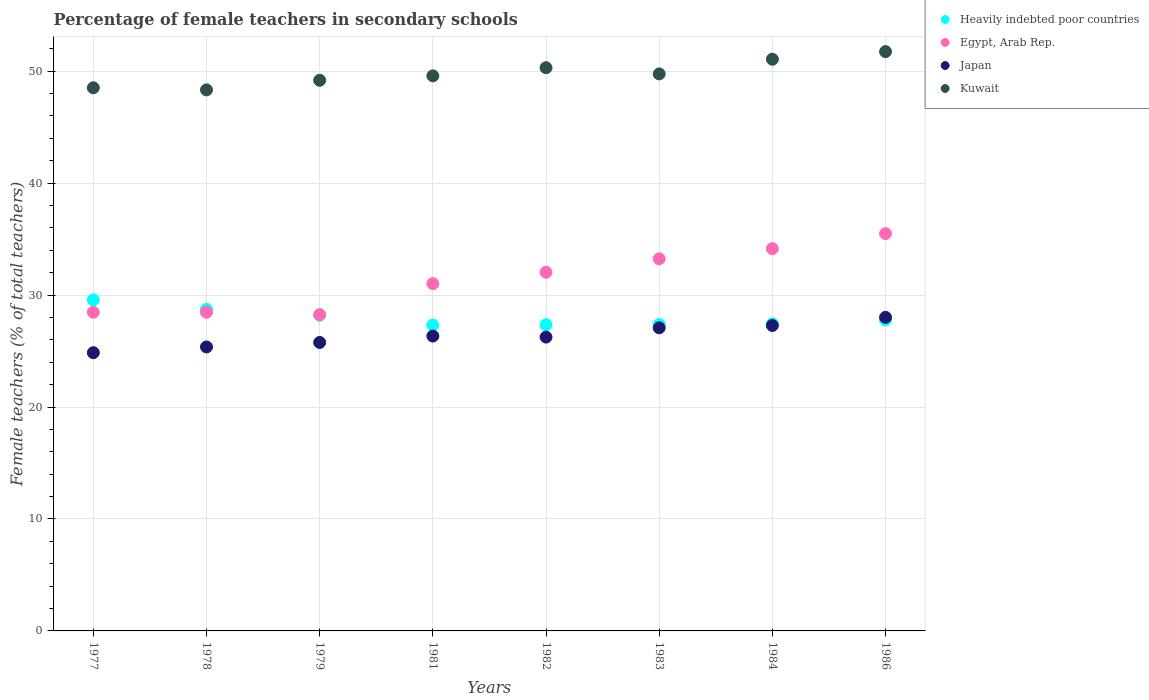Is the number of dotlines equal to the number of legend labels?
Offer a terse response. Yes. What is the percentage of female teachers in Kuwait in 1978?
Ensure brevity in your answer.  48.33. Across all years, what is the maximum percentage of female teachers in Heavily indebted poor countries?
Offer a terse response. 29.57. Across all years, what is the minimum percentage of female teachers in Kuwait?
Provide a succinct answer. 48.33. In which year was the percentage of female teachers in Kuwait minimum?
Give a very brief answer. 1978. What is the total percentage of female teachers in Heavily indebted poor countries in the graph?
Give a very brief answer. 223.78. What is the difference between the percentage of female teachers in Kuwait in 1978 and that in 1983?
Your answer should be very brief. -1.43. What is the difference between the percentage of female teachers in Egypt, Arab Rep. in 1979 and the percentage of female teachers in Kuwait in 1978?
Make the answer very short. -20.07. What is the average percentage of female teachers in Japan per year?
Ensure brevity in your answer.  26.37. In the year 1979, what is the difference between the percentage of female teachers in Egypt, Arab Rep. and percentage of female teachers in Japan?
Your response must be concise. 2.49. In how many years, is the percentage of female teachers in Kuwait greater than 30 %?
Provide a succinct answer. 8. What is the ratio of the percentage of female teachers in Egypt, Arab Rep. in 1979 to that in 1983?
Your answer should be very brief. 0.85. What is the difference between the highest and the second highest percentage of female teachers in Egypt, Arab Rep.?
Ensure brevity in your answer.  1.35. What is the difference between the highest and the lowest percentage of female teachers in Egypt, Arab Rep.?
Ensure brevity in your answer.  7.24. In how many years, is the percentage of female teachers in Japan greater than the average percentage of female teachers in Japan taken over all years?
Provide a succinct answer. 3. Is the sum of the percentage of female teachers in Egypt, Arab Rep. in 1978 and 1986 greater than the maximum percentage of female teachers in Japan across all years?
Your response must be concise. Yes. Is it the case that in every year, the sum of the percentage of female teachers in Heavily indebted poor countries and percentage of female teachers in Japan  is greater than the sum of percentage of female teachers in Egypt, Arab Rep. and percentage of female teachers in Kuwait?
Provide a succinct answer. Yes. Does the percentage of female teachers in Kuwait monotonically increase over the years?
Provide a short and direct response. No. How many dotlines are there?
Make the answer very short. 4. How many years are there in the graph?
Your response must be concise. 8. Does the graph contain any zero values?
Give a very brief answer. No. Where does the legend appear in the graph?
Keep it short and to the point. Top right. What is the title of the graph?
Your response must be concise. Percentage of female teachers in secondary schools. What is the label or title of the X-axis?
Give a very brief answer. Years. What is the label or title of the Y-axis?
Offer a terse response. Female teachers (% of total teachers). What is the Female teachers (% of total teachers) in Heavily indebted poor countries in 1977?
Your answer should be very brief. 29.57. What is the Female teachers (% of total teachers) of Egypt, Arab Rep. in 1977?
Ensure brevity in your answer.  28.47. What is the Female teachers (% of total teachers) of Japan in 1977?
Your answer should be compact. 24.85. What is the Female teachers (% of total teachers) of Kuwait in 1977?
Keep it short and to the point. 48.52. What is the Female teachers (% of total teachers) in Heavily indebted poor countries in 1978?
Your response must be concise. 28.73. What is the Female teachers (% of total teachers) in Egypt, Arab Rep. in 1978?
Your response must be concise. 28.46. What is the Female teachers (% of total teachers) of Japan in 1978?
Provide a succinct answer. 25.37. What is the Female teachers (% of total teachers) of Kuwait in 1978?
Make the answer very short. 48.33. What is the Female teachers (% of total teachers) of Heavily indebted poor countries in 1979?
Ensure brevity in your answer.  28.2. What is the Female teachers (% of total teachers) of Egypt, Arab Rep. in 1979?
Provide a succinct answer. 28.26. What is the Female teachers (% of total teachers) of Japan in 1979?
Offer a very short reply. 25.77. What is the Female teachers (% of total teachers) in Kuwait in 1979?
Your answer should be compact. 49.19. What is the Female teachers (% of total teachers) of Heavily indebted poor countries in 1981?
Your response must be concise. 27.32. What is the Female teachers (% of total teachers) in Egypt, Arab Rep. in 1981?
Keep it short and to the point. 31.03. What is the Female teachers (% of total teachers) in Japan in 1981?
Your answer should be compact. 26.34. What is the Female teachers (% of total teachers) of Kuwait in 1981?
Your response must be concise. 49.58. What is the Female teachers (% of total teachers) in Heavily indebted poor countries in 1982?
Provide a succinct answer. 27.36. What is the Female teachers (% of total teachers) of Egypt, Arab Rep. in 1982?
Keep it short and to the point. 32.04. What is the Female teachers (% of total teachers) of Japan in 1982?
Provide a short and direct response. 26.25. What is the Female teachers (% of total teachers) of Kuwait in 1982?
Your response must be concise. 50.31. What is the Female teachers (% of total teachers) in Heavily indebted poor countries in 1983?
Provide a succinct answer. 27.38. What is the Female teachers (% of total teachers) of Egypt, Arab Rep. in 1983?
Your answer should be very brief. 33.24. What is the Female teachers (% of total teachers) of Japan in 1983?
Make the answer very short. 27.08. What is the Female teachers (% of total teachers) in Kuwait in 1983?
Provide a short and direct response. 49.76. What is the Female teachers (% of total teachers) in Heavily indebted poor countries in 1984?
Your answer should be compact. 27.44. What is the Female teachers (% of total teachers) in Egypt, Arab Rep. in 1984?
Offer a very short reply. 34.15. What is the Female teachers (% of total teachers) in Japan in 1984?
Keep it short and to the point. 27.28. What is the Female teachers (% of total teachers) of Kuwait in 1984?
Offer a terse response. 51.07. What is the Female teachers (% of total teachers) in Heavily indebted poor countries in 1986?
Offer a very short reply. 27.79. What is the Female teachers (% of total teachers) of Egypt, Arab Rep. in 1986?
Give a very brief answer. 35.49. What is the Female teachers (% of total teachers) of Japan in 1986?
Offer a terse response. 28.01. What is the Female teachers (% of total teachers) of Kuwait in 1986?
Provide a succinct answer. 51.75. Across all years, what is the maximum Female teachers (% of total teachers) in Heavily indebted poor countries?
Offer a terse response. 29.57. Across all years, what is the maximum Female teachers (% of total teachers) in Egypt, Arab Rep.?
Ensure brevity in your answer.  35.49. Across all years, what is the maximum Female teachers (% of total teachers) of Japan?
Ensure brevity in your answer.  28.01. Across all years, what is the maximum Female teachers (% of total teachers) in Kuwait?
Make the answer very short. 51.75. Across all years, what is the minimum Female teachers (% of total teachers) in Heavily indebted poor countries?
Provide a succinct answer. 27.32. Across all years, what is the minimum Female teachers (% of total teachers) in Egypt, Arab Rep.?
Keep it short and to the point. 28.26. Across all years, what is the minimum Female teachers (% of total teachers) of Japan?
Your response must be concise. 24.85. Across all years, what is the minimum Female teachers (% of total teachers) of Kuwait?
Keep it short and to the point. 48.33. What is the total Female teachers (% of total teachers) of Heavily indebted poor countries in the graph?
Provide a short and direct response. 223.78. What is the total Female teachers (% of total teachers) of Egypt, Arab Rep. in the graph?
Your response must be concise. 251.14. What is the total Female teachers (% of total teachers) in Japan in the graph?
Give a very brief answer. 210.95. What is the total Female teachers (% of total teachers) of Kuwait in the graph?
Provide a succinct answer. 398.5. What is the difference between the Female teachers (% of total teachers) in Heavily indebted poor countries in 1977 and that in 1978?
Your response must be concise. 0.84. What is the difference between the Female teachers (% of total teachers) of Egypt, Arab Rep. in 1977 and that in 1978?
Your answer should be compact. 0. What is the difference between the Female teachers (% of total teachers) in Japan in 1977 and that in 1978?
Provide a succinct answer. -0.51. What is the difference between the Female teachers (% of total teachers) in Kuwait in 1977 and that in 1978?
Give a very brief answer. 0.19. What is the difference between the Female teachers (% of total teachers) of Heavily indebted poor countries in 1977 and that in 1979?
Provide a short and direct response. 1.37. What is the difference between the Female teachers (% of total teachers) in Egypt, Arab Rep. in 1977 and that in 1979?
Your answer should be very brief. 0.21. What is the difference between the Female teachers (% of total teachers) of Japan in 1977 and that in 1979?
Ensure brevity in your answer.  -0.91. What is the difference between the Female teachers (% of total teachers) in Kuwait in 1977 and that in 1979?
Keep it short and to the point. -0.67. What is the difference between the Female teachers (% of total teachers) in Heavily indebted poor countries in 1977 and that in 1981?
Make the answer very short. 2.25. What is the difference between the Female teachers (% of total teachers) in Egypt, Arab Rep. in 1977 and that in 1981?
Your answer should be very brief. -2.56. What is the difference between the Female teachers (% of total teachers) in Japan in 1977 and that in 1981?
Give a very brief answer. -1.49. What is the difference between the Female teachers (% of total teachers) of Kuwait in 1977 and that in 1981?
Your response must be concise. -1.07. What is the difference between the Female teachers (% of total teachers) of Heavily indebted poor countries in 1977 and that in 1982?
Offer a very short reply. 2.21. What is the difference between the Female teachers (% of total teachers) in Egypt, Arab Rep. in 1977 and that in 1982?
Offer a terse response. -3.57. What is the difference between the Female teachers (% of total teachers) of Japan in 1977 and that in 1982?
Your answer should be compact. -1.39. What is the difference between the Female teachers (% of total teachers) in Kuwait in 1977 and that in 1982?
Make the answer very short. -1.79. What is the difference between the Female teachers (% of total teachers) of Heavily indebted poor countries in 1977 and that in 1983?
Ensure brevity in your answer.  2.19. What is the difference between the Female teachers (% of total teachers) in Egypt, Arab Rep. in 1977 and that in 1983?
Your response must be concise. -4.78. What is the difference between the Female teachers (% of total teachers) in Japan in 1977 and that in 1983?
Make the answer very short. -2.22. What is the difference between the Female teachers (% of total teachers) of Kuwait in 1977 and that in 1983?
Make the answer very short. -1.24. What is the difference between the Female teachers (% of total teachers) of Heavily indebted poor countries in 1977 and that in 1984?
Your response must be concise. 2.14. What is the difference between the Female teachers (% of total teachers) of Egypt, Arab Rep. in 1977 and that in 1984?
Keep it short and to the point. -5.68. What is the difference between the Female teachers (% of total teachers) of Japan in 1977 and that in 1984?
Make the answer very short. -2.43. What is the difference between the Female teachers (% of total teachers) in Kuwait in 1977 and that in 1984?
Your response must be concise. -2.55. What is the difference between the Female teachers (% of total teachers) in Heavily indebted poor countries in 1977 and that in 1986?
Ensure brevity in your answer.  1.79. What is the difference between the Female teachers (% of total teachers) in Egypt, Arab Rep. in 1977 and that in 1986?
Make the answer very short. -7.03. What is the difference between the Female teachers (% of total teachers) in Japan in 1977 and that in 1986?
Give a very brief answer. -3.16. What is the difference between the Female teachers (% of total teachers) of Kuwait in 1977 and that in 1986?
Offer a very short reply. -3.23. What is the difference between the Female teachers (% of total teachers) in Heavily indebted poor countries in 1978 and that in 1979?
Ensure brevity in your answer.  0.54. What is the difference between the Female teachers (% of total teachers) in Egypt, Arab Rep. in 1978 and that in 1979?
Ensure brevity in your answer.  0.21. What is the difference between the Female teachers (% of total teachers) of Japan in 1978 and that in 1979?
Give a very brief answer. -0.4. What is the difference between the Female teachers (% of total teachers) of Kuwait in 1978 and that in 1979?
Your response must be concise. -0.86. What is the difference between the Female teachers (% of total teachers) of Heavily indebted poor countries in 1978 and that in 1981?
Your answer should be compact. 1.41. What is the difference between the Female teachers (% of total teachers) in Egypt, Arab Rep. in 1978 and that in 1981?
Make the answer very short. -2.56. What is the difference between the Female teachers (% of total teachers) of Japan in 1978 and that in 1981?
Offer a very short reply. -0.97. What is the difference between the Female teachers (% of total teachers) in Kuwait in 1978 and that in 1981?
Make the answer very short. -1.25. What is the difference between the Female teachers (% of total teachers) in Heavily indebted poor countries in 1978 and that in 1982?
Provide a succinct answer. 1.38. What is the difference between the Female teachers (% of total teachers) in Egypt, Arab Rep. in 1978 and that in 1982?
Provide a succinct answer. -3.58. What is the difference between the Female teachers (% of total teachers) in Japan in 1978 and that in 1982?
Offer a terse response. -0.88. What is the difference between the Female teachers (% of total teachers) of Kuwait in 1978 and that in 1982?
Keep it short and to the point. -1.98. What is the difference between the Female teachers (% of total teachers) of Heavily indebted poor countries in 1978 and that in 1983?
Provide a succinct answer. 1.36. What is the difference between the Female teachers (% of total teachers) in Egypt, Arab Rep. in 1978 and that in 1983?
Keep it short and to the point. -4.78. What is the difference between the Female teachers (% of total teachers) of Japan in 1978 and that in 1983?
Provide a short and direct response. -1.71. What is the difference between the Female teachers (% of total teachers) of Kuwait in 1978 and that in 1983?
Keep it short and to the point. -1.43. What is the difference between the Female teachers (% of total teachers) of Heavily indebted poor countries in 1978 and that in 1984?
Your response must be concise. 1.3. What is the difference between the Female teachers (% of total teachers) of Egypt, Arab Rep. in 1978 and that in 1984?
Offer a very short reply. -5.68. What is the difference between the Female teachers (% of total teachers) of Japan in 1978 and that in 1984?
Provide a succinct answer. -1.92. What is the difference between the Female teachers (% of total teachers) of Kuwait in 1978 and that in 1984?
Offer a terse response. -2.74. What is the difference between the Female teachers (% of total teachers) in Heavily indebted poor countries in 1978 and that in 1986?
Keep it short and to the point. 0.95. What is the difference between the Female teachers (% of total teachers) in Egypt, Arab Rep. in 1978 and that in 1986?
Your response must be concise. -7.03. What is the difference between the Female teachers (% of total teachers) in Japan in 1978 and that in 1986?
Make the answer very short. -2.64. What is the difference between the Female teachers (% of total teachers) in Kuwait in 1978 and that in 1986?
Your answer should be compact. -3.42. What is the difference between the Female teachers (% of total teachers) in Heavily indebted poor countries in 1979 and that in 1981?
Ensure brevity in your answer.  0.88. What is the difference between the Female teachers (% of total teachers) in Egypt, Arab Rep. in 1979 and that in 1981?
Make the answer very short. -2.77. What is the difference between the Female teachers (% of total teachers) in Japan in 1979 and that in 1981?
Give a very brief answer. -0.57. What is the difference between the Female teachers (% of total teachers) in Kuwait in 1979 and that in 1981?
Provide a short and direct response. -0.4. What is the difference between the Female teachers (% of total teachers) of Heavily indebted poor countries in 1979 and that in 1982?
Your answer should be very brief. 0.84. What is the difference between the Female teachers (% of total teachers) in Egypt, Arab Rep. in 1979 and that in 1982?
Your response must be concise. -3.78. What is the difference between the Female teachers (% of total teachers) of Japan in 1979 and that in 1982?
Give a very brief answer. -0.48. What is the difference between the Female teachers (% of total teachers) in Kuwait in 1979 and that in 1982?
Your response must be concise. -1.12. What is the difference between the Female teachers (% of total teachers) in Heavily indebted poor countries in 1979 and that in 1983?
Offer a terse response. 0.82. What is the difference between the Female teachers (% of total teachers) of Egypt, Arab Rep. in 1979 and that in 1983?
Your response must be concise. -4.99. What is the difference between the Female teachers (% of total teachers) of Japan in 1979 and that in 1983?
Make the answer very short. -1.31. What is the difference between the Female teachers (% of total teachers) in Kuwait in 1979 and that in 1983?
Offer a terse response. -0.57. What is the difference between the Female teachers (% of total teachers) in Heavily indebted poor countries in 1979 and that in 1984?
Your answer should be compact. 0.76. What is the difference between the Female teachers (% of total teachers) in Egypt, Arab Rep. in 1979 and that in 1984?
Keep it short and to the point. -5.89. What is the difference between the Female teachers (% of total teachers) in Japan in 1979 and that in 1984?
Provide a succinct answer. -1.52. What is the difference between the Female teachers (% of total teachers) in Kuwait in 1979 and that in 1984?
Ensure brevity in your answer.  -1.88. What is the difference between the Female teachers (% of total teachers) in Heavily indebted poor countries in 1979 and that in 1986?
Your response must be concise. 0.41. What is the difference between the Female teachers (% of total teachers) of Egypt, Arab Rep. in 1979 and that in 1986?
Offer a terse response. -7.24. What is the difference between the Female teachers (% of total teachers) in Japan in 1979 and that in 1986?
Give a very brief answer. -2.24. What is the difference between the Female teachers (% of total teachers) in Kuwait in 1979 and that in 1986?
Give a very brief answer. -2.56. What is the difference between the Female teachers (% of total teachers) in Heavily indebted poor countries in 1981 and that in 1982?
Keep it short and to the point. -0.04. What is the difference between the Female teachers (% of total teachers) of Egypt, Arab Rep. in 1981 and that in 1982?
Your answer should be very brief. -1.01. What is the difference between the Female teachers (% of total teachers) of Japan in 1981 and that in 1982?
Your answer should be compact. 0.09. What is the difference between the Female teachers (% of total teachers) of Kuwait in 1981 and that in 1982?
Your answer should be compact. -0.73. What is the difference between the Female teachers (% of total teachers) of Heavily indebted poor countries in 1981 and that in 1983?
Your answer should be very brief. -0.06. What is the difference between the Female teachers (% of total teachers) in Egypt, Arab Rep. in 1981 and that in 1983?
Offer a very short reply. -2.22. What is the difference between the Female teachers (% of total teachers) of Japan in 1981 and that in 1983?
Your answer should be very brief. -0.74. What is the difference between the Female teachers (% of total teachers) of Kuwait in 1981 and that in 1983?
Give a very brief answer. -0.18. What is the difference between the Female teachers (% of total teachers) of Heavily indebted poor countries in 1981 and that in 1984?
Provide a short and direct response. -0.12. What is the difference between the Female teachers (% of total teachers) in Egypt, Arab Rep. in 1981 and that in 1984?
Ensure brevity in your answer.  -3.12. What is the difference between the Female teachers (% of total teachers) in Japan in 1981 and that in 1984?
Make the answer very short. -0.94. What is the difference between the Female teachers (% of total teachers) in Kuwait in 1981 and that in 1984?
Ensure brevity in your answer.  -1.49. What is the difference between the Female teachers (% of total teachers) of Heavily indebted poor countries in 1981 and that in 1986?
Give a very brief answer. -0.46. What is the difference between the Female teachers (% of total teachers) of Egypt, Arab Rep. in 1981 and that in 1986?
Keep it short and to the point. -4.47. What is the difference between the Female teachers (% of total teachers) in Japan in 1981 and that in 1986?
Provide a short and direct response. -1.67. What is the difference between the Female teachers (% of total teachers) in Kuwait in 1981 and that in 1986?
Offer a very short reply. -2.17. What is the difference between the Female teachers (% of total teachers) of Heavily indebted poor countries in 1982 and that in 1983?
Your answer should be very brief. -0.02. What is the difference between the Female teachers (% of total teachers) in Egypt, Arab Rep. in 1982 and that in 1983?
Your answer should be compact. -1.2. What is the difference between the Female teachers (% of total teachers) of Japan in 1982 and that in 1983?
Provide a short and direct response. -0.83. What is the difference between the Female teachers (% of total teachers) of Kuwait in 1982 and that in 1983?
Keep it short and to the point. 0.55. What is the difference between the Female teachers (% of total teachers) of Heavily indebted poor countries in 1982 and that in 1984?
Offer a very short reply. -0.08. What is the difference between the Female teachers (% of total teachers) of Egypt, Arab Rep. in 1982 and that in 1984?
Your answer should be very brief. -2.11. What is the difference between the Female teachers (% of total teachers) of Japan in 1982 and that in 1984?
Make the answer very short. -1.04. What is the difference between the Female teachers (% of total teachers) of Kuwait in 1982 and that in 1984?
Make the answer very short. -0.76. What is the difference between the Female teachers (% of total teachers) in Heavily indebted poor countries in 1982 and that in 1986?
Your answer should be compact. -0.43. What is the difference between the Female teachers (% of total teachers) of Egypt, Arab Rep. in 1982 and that in 1986?
Ensure brevity in your answer.  -3.45. What is the difference between the Female teachers (% of total teachers) in Japan in 1982 and that in 1986?
Offer a very short reply. -1.76. What is the difference between the Female teachers (% of total teachers) of Kuwait in 1982 and that in 1986?
Your answer should be very brief. -1.44. What is the difference between the Female teachers (% of total teachers) of Heavily indebted poor countries in 1983 and that in 1984?
Give a very brief answer. -0.06. What is the difference between the Female teachers (% of total teachers) in Egypt, Arab Rep. in 1983 and that in 1984?
Your response must be concise. -0.9. What is the difference between the Female teachers (% of total teachers) of Japan in 1983 and that in 1984?
Ensure brevity in your answer.  -0.21. What is the difference between the Female teachers (% of total teachers) in Kuwait in 1983 and that in 1984?
Provide a short and direct response. -1.31. What is the difference between the Female teachers (% of total teachers) in Heavily indebted poor countries in 1983 and that in 1986?
Offer a terse response. -0.41. What is the difference between the Female teachers (% of total teachers) in Egypt, Arab Rep. in 1983 and that in 1986?
Your answer should be compact. -2.25. What is the difference between the Female teachers (% of total teachers) of Japan in 1983 and that in 1986?
Offer a very short reply. -0.93. What is the difference between the Female teachers (% of total teachers) of Kuwait in 1983 and that in 1986?
Make the answer very short. -1.99. What is the difference between the Female teachers (% of total teachers) in Heavily indebted poor countries in 1984 and that in 1986?
Offer a terse response. -0.35. What is the difference between the Female teachers (% of total teachers) in Egypt, Arab Rep. in 1984 and that in 1986?
Give a very brief answer. -1.35. What is the difference between the Female teachers (% of total teachers) in Japan in 1984 and that in 1986?
Give a very brief answer. -0.73. What is the difference between the Female teachers (% of total teachers) in Kuwait in 1984 and that in 1986?
Offer a very short reply. -0.68. What is the difference between the Female teachers (% of total teachers) of Heavily indebted poor countries in 1977 and the Female teachers (% of total teachers) of Egypt, Arab Rep. in 1978?
Your answer should be very brief. 1.11. What is the difference between the Female teachers (% of total teachers) of Heavily indebted poor countries in 1977 and the Female teachers (% of total teachers) of Japan in 1978?
Your answer should be very brief. 4.2. What is the difference between the Female teachers (% of total teachers) in Heavily indebted poor countries in 1977 and the Female teachers (% of total teachers) in Kuwait in 1978?
Provide a short and direct response. -18.76. What is the difference between the Female teachers (% of total teachers) of Egypt, Arab Rep. in 1977 and the Female teachers (% of total teachers) of Japan in 1978?
Your answer should be compact. 3.1. What is the difference between the Female teachers (% of total teachers) in Egypt, Arab Rep. in 1977 and the Female teachers (% of total teachers) in Kuwait in 1978?
Your response must be concise. -19.86. What is the difference between the Female teachers (% of total teachers) in Japan in 1977 and the Female teachers (% of total teachers) in Kuwait in 1978?
Make the answer very short. -23.48. What is the difference between the Female teachers (% of total teachers) in Heavily indebted poor countries in 1977 and the Female teachers (% of total teachers) in Egypt, Arab Rep. in 1979?
Your response must be concise. 1.32. What is the difference between the Female teachers (% of total teachers) in Heavily indebted poor countries in 1977 and the Female teachers (% of total teachers) in Japan in 1979?
Offer a very short reply. 3.8. What is the difference between the Female teachers (% of total teachers) in Heavily indebted poor countries in 1977 and the Female teachers (% of total teachers) in Kuwait in 1979?
Ensure brevity in your answer.  -19.62. What is the difference between the Female teachers (% of total teachers) of Egypt, Arab Rep. in 1977 and the Female teachers (% of total teachers) of Japan in 1979?
Provide a succinct answer. 2.7. What is the difference between the Female teachers (% of total teachers) in Egypt, Arab Rep. in 1977 and the Female teachers (% of total teachers) in Kuwait in 1979?
Keep it short and to the point. -20.72. What is the difference between the Female teachers (% of total teachers) of Japan in 1977 and the Female teachers (% of total teachers) of Kuwait in 1979?
Ensure brevity in your answer.  -24.33. What is the difference between the Female teachers (% of total teachers) in Heavily indebted poor countries in 1977 and the Female teachers (% of total teachers) in Egypt, Arab Rep. in 1981?
Give a very brief answer. -1.45. What is the difference between the Female teachers (% of total teachers) of Heavily indebted poor countries in 1977 and the Female teachers (% of total teachers) of Japan in 1981?
Provide a succinct answer. 3.23. What is the difference between the Female teachers (% of total teachers) in Heavily indebted poor countries in 1977 and the Female teachers (% of total teachers) in Kuwait in 1981?
Your answer should be very brief. -20.01. What is the difference between the Female teachers (% of total teachers) of Egypt, Arab Rep. in 1977 and the Female teachers (% of total teachers) of Japan in 1981?
Ensure brevity in your answer.  2.13. What is the difference between the Female teachers (% of total teachers) in Egypt, Arab Rep. in 1977 and the Female teachers (% of total teachers) in Kuwait in 1981?
Provide a short and direct response. -21.12. What is the difference between the Female teachers (% of total teachers) in Japan in 1977 and the Female teachers (% of total teachers) in Kuwait in 1981?
Make the answer very short. -24.73. What is the difference between the Female teachers (% of total teachers) in Heavily indebted poor countries in 1977 and the Female teachers (% of total teachers) in Egypt, Arab Rep. in 1982?
Offer a terse response. -2.47. What is the difference between the Female teachers (% of total teachers) of Heavily indebted poor countries in 1977 and the Female teachers (% of total teachers) of Japan in 1982?
Give a very brief answer. 3.32. What is the difference between the Female teachers (% of total teachers) in Heavily indebted poor countries in 1977 and the Female teachers (% of total teachers) in Kuwait in 1982?
Keep it short and to the point. -20.74. What is the difference between the Female teachers (% of total teachers) in Egypt, Arab Rep. in 1977 and the Female teachers (% of total teachers) in Japan in 1982?
Ensure brevity in your answer.  2.22. What is the difference between the Female teachers (% of total teachers) of Egypt, Arab Rep. in 1977 and the Female teachers (% of total teachers) of Kuwait in 1982?
Your answer should be very brief. -21.84. What is the difference between the Female teachers (% of total teachers) in Japan in 1977 and the Female teachers (% of total teachers) in Kuwait in 1982?
Give a very brief answer. -25.45. What is the difference between the Female teachers (% of total teachers) in Heavily indebted poor countries in 1977 and the Female teachers (% of total teachers) in Egypt, Arab Rep. in 1983?
Provide a succinct answer. -3.67. What is the difference between the Female teachers (% of total teachers) of Heavily indebted poor countries in 1977 and the Female teachers (% of total teachers) of Japan in 1983?
Your answer should be compact. 2.5. What is the difference between the Female teachers (% of total teachers) of Heavily indebted poor countries in 1977 and the Female teachers (% of total teachers) of Kuwait in 1983?
Offer a terse response. -20.19. What is the difference between the Female teachers (% of total teachers) in Egypt, Arab Rep. in 1977 and the Female teachers (% of total teachers) in Japan in 1983?
Offer a very short reply. 1.39. What is the difference between the Female teachers (% of total teachers) of Egypt, Arab Rep. in 1977 and the Female teachers (% of total teachers) of Kuwait in 1983?
Ensure brevity in your answer.  -21.29. What is the difference between the Female teachers (% of total teachers) of Japan in 1977 and the Female teachers (% of total teachers) of Kuwait in 1983?
Provide a short and direct response. -24.9. What is the difference between the Female teachers (% of total teachers) in Heavily indebted poor countries in 1977 and the Female teachers (% of total teachers) in Egypt, Arab Rep. in 1984?
Ensure brevity in your answer.  -4.57. What is the difference between the Female teachers (% of total teachers) of Heavily indebted poor countries in 1977 and the Female teachers (% of total teachers) of Japan in 1984?
Offer a terse response. 2.29. What is the difference between the Female teachers (% of total teachers) in Heavily indebted poor countries in 1977 and the Female teachers (% of total teachers) in Kuwait in 1984?
Keep it short and to the point. -21.5. What is the difference between the Female teachers (% of total teachers) of Egypt, Arab Rep. in 1977 and the Female teachers (% of total teachers) of Japan in 1984?
Offer a very short reply. 1.18. What is the difference between the Female teachers (% of total teachers) in Egypt, Arab Rep. in 1977 and the Female teachers (% of total teachers) in Kuwait in 1984?
Ensure brevity in your answer.  -22.6. What is the difference between the Female teachers (% of total teachers) in Japan in 1977 and the Female teachers (% of total teachers) in Kuwait in 1984?
Keep it short and to the point. -26.22. What is the difference between the Female teachers (% of total teachers) of Heavily indebted poor countries in 1977 and the Female teachers (% of total teachers) of Egypt, Arab Rep. in 1986?
Offer a terse response. -5.92. What is the difference between the Female teachers (% of total teachers) of Heavily indebted poor countries in 1977 and the Female teachers (% of total teachers) of Japan in 1986?
Provide a succinct answer. 1.56. What is the difference between the Female teachers (% of total teachers) in Heavily indebted poor countries in 1977 and the Female teachers (% of total teachers) in Kuwait in 1986?
Provide a short and direct response. -22.18. What is the difference between the Female teachers (% of total teachers) of Egypt, Arab Rep. in 1977 and the Female teachers (% of total teachers) of Japan in 1986?
Provide a short and direct response. 0.46. What is the difference between the Female teachers (% of total teachers) in Egypt, Arab Rep. in 1977 and the Female teachers (% of total teachers) in Kuwait in 1986?
Make the answer very short. -23.28. What is the difference between the Female teachers (% of total teachers) in Japan in 1977 and the Female teachers (% of total teachers) in Kuwait in 1986?
Provide a succinct answer. -26.89. What is the difference between the Female teachers (% of total teachers) in Heavily indebted poor countries in 1978 and the Female teachers (% of total teachers) in Egypt, Arab Rep. in 1979?
Provide a succinct answer. 0.48. What is the difference between the Female teachers (% of total teachers) in Heavily indebted poor countries in 1978 and the Female teachers (% of total teachers) in Japan in 1979?
Your answer should be very brief. 2.97. What is the difference between the Female teachers (% of total teachers) of Heavily indebted poor countries in 1978 and the Female teachers (% of total teachers) of Kuwait in 1979?
Provide a succinct answer. -20.45. What is the difference between the Female teachers (% of total teachers) of Egypt, Arab Rep. in 1978 and the Female teachers (% of total teachers) of Japan in 1979?
Your answer should be compact. 2.7. What is the difference between the Female teachers (% of total teachers) in Egypt, Arab Rep. in 1978 and the Female teachers (% of total teachers) in Kuwait in 1979?
Ensure brevity in your answer.  -20.72. What is the difference between the Female teachers (% of total teachers) of Japan in 1978 and the Female teachers (% of total teachers) of Kuwait in 1979?
Keep it short and to the point. -23.82. What is the difference between the Female teachers (% of total teachers) of Heavily indebted poor countries in 1978 and the Female teachers (% of total teachers) of Egypt, Arab Rep. in 1981?
Your answer should be compact. -2.29. What is the difference between the Female teachers (% of total teachers) in Heavily indebted poor countries in 1978 and the Female teachers (% of total teachers) in Japan in 1981?
Your response must be concise. 2.4. What is the difference between the Female teachers (% of total teachers) in Heavily indebted poor countries in 1978 and the Female teachers (% of total teachers) in Kuwait in 1981?
Your answer should be very brief. -20.85. What is the difference between the Female teachers (% of total teachers) in Egypt, Arab Rep. in 1978 and the Female teachers (% of total teachers) in Japan in 1981?
Provide a short and direct response. 2.12. What is the difference between the Female teachers (% of total teachers) of Egypt, Arab Rep. in 1978 and the Female teachers (% of total teachers) of Kuwait in 1981?
Make the answer very short. -21.12. What is the difference between the Female teachers (% of total teachers) in Japan in 1978 and the Female teachers (% of total teachers) in Kuwait in 1981?
Make the answer very short. -24.22. What is the difference between the Female teachers (% of total teachers) in Heavily indebted poor countries in 1978 and the Female teachers (% of total teachers) in Egypt, Arab Rep. in 1982?
Your response must be concise. -3.31. What is the difference between the Female teachers (% of total teachers) in Heavily indebted poor countries in 1978 and the Female teachers (% of total teachers) in Japan in 1982?
Your answer should be very brief. 2.49. What is the difference between the Female teachers (% of total teachers) in Heavily indebted poor countries in 1978 and the Female teachers (% of total teachers) in Kuwait in 1982?
Your answer should be compact. -21.57. What is the difference between the Female teachers (% of total teachers) in Egypt, Arab Rep. in 1978 and the Female teachers (% of total teachers) in Japan in 1982?
Provide a short and direct response. 2.22. What is the difference between the Female teachers (% of total teachers) of Egypt, Arab Rep. in 1978 and the Female teachers (% of total teachers) of Kuwait in 1982?
Keep it short and to the point. -21.85. What is the difference between the Female teachers (% of total teachers) in Japan in 1978 and the Female teachers (% of total teachers) in Kuwait in 1982?
Offer a terse response. -24.94. What is the difference between the Female teachers (% of total teachers) in Heavily indebted poor countries in 1978 and the Female teachers (% of total teachers) in Egypt, Arab Rep. in 1983?
Offer a very short reply. -4.51. What is the difference between the Female teachers (% of total teachers) in Heavily indebted poor countries in 1978 and the Female teachers (% of total teachers) in Japan in 1983?
Your answer should be very brief. 1.66. What is the difference between the Female teachers (% of total teachers) of Heavily indebted poor countries in 1978 and the Female teachers (% of total teachers) of Kuwait in 1983?
Your response must be concise. -21.02. What is the difference between the Female teachers (% of total teachers) of Egypt, Arab Rep. in 1978 and the Female teachers (% of total teachers) of Japan in 1983?
Provide a short and direct response. 1.39. What is the difference between the Female teachers (% of total teachers) of Egypt, Arab Rep. in 1978 and the Female teachers (% of total teachers) of Kuwait in 1983?
Provide a short and direct response. -21.29. What is the difference between the Female teachers (% of total teachers) of Japan in 1978 and the Female teachers (% of total teachers) of Kuwait in 1983?
Make the answer very short. -24.39. What is the difference between the Female teachers (% of total teachers) in Heavily indebted poor countries in 1978 and the Female teachers (% of total teachers) in Egypt, Arab Rep. in 1984?
Provide a short and direct response. -5.41. What is the difference between the Female teachers (% of total teachers) in Heavily indebted poor countries in 1978 and the Female teachers (% of total teachers) in Japan in 1984?
Your response must be concise. 1.45. What is the difference between the Female teachers (% of total teachers) of Heavily indebted poor countries in 1978 and the Female teachers (% of total teachers) of Kuwait in 1984?
Your response must be concise. -22.33. What is the difference between the Female teachers (% of total teachers) of Egypt, Arab Rep. in 1978 and the Female teachers (% of total teachers) of Japan in 1984?
Ensure brevity in your answer.  1.18. What is the difference between the Female teachers (% of total teachers) of Egypt, Arab Rep. in 1978 and the Female teachers (% of total teachers) of Kuwait in 1984?
Provide a succinct answer. -22.61. What is the difference between the Female teachers (% of total teachers) of Japan in 1978 and the Female teachers (% of total teachers) of Kuwait in 1984?
Give a very brief answer. -25.7. What is the difference between the Female teachers (% of total teachers) in Heavily indebted poor countries in 1978 and the Female teachers (% of total teachers) in Egypt, Arab Rep. in 1986?
Your answer should be compact. -6.76. What is the difference between the Female teachers (% of total teachers) of Heavily indebted poor countries in 1978 and the Female teachers (% of total teachers) of Japan in 1986?
Offer a very short reply. 0.72. What is the difference between the Female teachers (% of total teachers) of Heavily indebted poor countries in 1978 and the Female teachers (% of total teachers) of Kuwait in 1986?
Give a very brief answer. -23.01. What is the difference between the Female teachers (% of total teachers) in Egypt, Arab Rep. in 1978 and the Female teachers (% of total teachers) in Japan in 1986?
Offer a very short reply. 0.45. What is the difference between the Female teachers (% of total teachers) of Egypt, Arab Rep. in 1978 and the Female teachers (% of total teachers) of Kuwait in 1986?
Keep it short and to the point. -23.28. What is the difference between the Female teachers (% of total teachers) of Japan in 1978 and the Female teachers (% of total teachers) of Kuwait in 1986?
Give a very brief answer. -26.38. What is the difference between the Female teachers (% of total teachers) in Heavily indebted poor countries in 1979 and the Female teachers (% of total teachers) in Egypt, Arab Rep. in 1981?
Keep it short and to the point. -2.83. What is the difference between the Female teachers (% of total teachers) of Heavily indebted poor countries in 1979 and the Female teachers (% of total teachers) of Japan in 1981?
Give a very brief answer. 1.86. What is the difference between the Female teachers (% of total teachers) of Heavily indebted poor countries in 1979 and the Female teachers (% of total teachers) of Kuwait in 1981?
Provide a succinct answer. -21.38. What is the difference between the Female teachers (% of total teachers) of Egypt, Arab Rep. in 1979 and the Female teachers (% of total teachers) of Japan in 1981?
Provide a short and direct response. 1.92. What is the difference between the Female teachers (% of total teachers) of Egypt, Arab Rep. in 1979 and the Female teachers (% of total teachers) of Kuwait in 1981?
Provide a short and direct response. -21.33. What is the difference between the Female teachers (% of total teachers) of Japan in 1979 and the Female teachers (% of total teachers) of Kuwait in 1981?
Provide a short and direct response. -23.81. What is the difference between the Female teachers (% of total teachers) in Heavily indebted poor countries in 1979 and the Female teachers (% of total teachers) in Egypt, Arab Rep. in 1982?
Offer a very short reply. -3.84. What is the difference between the Female teachers (% of total teachers) in Heavily indebted poor countries in 1979 and the Female teachers (% of total teachers) in Japan in 1982?
Offer a very short reply. 1.95. What is the difference between the Female teachers (% of total teachers) in Heavily indebted poor countries in 1979 and the Female teachers (% of total teachers) in Kuwait in 1982?
Give a very brief answer. -22.11. What is the difference between the Female teachers (% of total teachers) in Egypt, Arab Rep. in 1979 and the Female teachers (% of total teachers) in Japan in 1982?
Provide a short and direct response. 2.01. What is the difference between the Female teachers (% of total teachers) of Egypt, Arab Rep. in 1979 and the Female teachers (% of total teachers) of Kuwait in 1982?
Offer a very short reply. -22.05. What is the difference between the Female teachers (% of total teachers) of Japan in 1979 and the Female teachers (% of total teachers) of Kuwait in 1982?
Provide a succinct answer. -24.54. What is the difference between the Female teachers (% of total teachers) of Heavily indebted poor countries in 1979 and the Female teachers (% of total teachers) of Egypt, Arab Rep. in 1983?
Provide a short and direct response. -5.04. What is the difference between the Female teachers (% of total teachers) of Heavily indebted poor countries in 1979 and the Female teachers (% of total teachers) of Japan in 1983?
Offer a terse response. 1.12. What is the difference between the Female teachers (% of total teachers) in Heavily indebted poor countries in 1979 and the Female teachers (% of total teachers) in Kuwait in 1983?
Provide a short and direct response. -21.56. What is the difference between the Female teachers (% of total teachers) in Egypt, Arab Rep. in 1979 and the Female teachers (% of total teachers) in Japan in 1983?
Provide a short and direct response. 1.18. What is the difference between the Female teachers (% of total teachers) in Egypt, Arab Rep. in 1979 and the Female teachers (% of total teachers) in Kuwait in 1983?
Provide a short and direct response. -21.5. What is the difference between the Female teachers (% of total teachers) in Japan in 1979 and the Female teachers (% of total teachers) in Kuwait in 1983?
Provide a succinct answer. -23.99. What is the difference between the Female teachers (% of total teachers) of Heavily indebted poor countries in 1979 and the Female teachers (% of total teachers) of Egypt, Arab Rep. in 1984?
Give a very brief answer. -5.95. What is the difference between the Female teachers (% of total teachers) of Heavily indebted poor countries in 1979 and the Female teachers (% of total teachers) of Japan in 1984?
Your answer should be compact. 0.92. What is the difference between the Female teachers (% of total teachers) in Heavily indebted poor countries in 1979 and the Female teachers (% of total teachers) in Kuwait in 1984?
Your answer should be very brief. -22.87. What is the difference between the Female teachers (% of total teachers) of Egypt, Arab Rep. in 1979 and the Female teachers (% of total teachers) of Japan in 1984?
Your answer should be compact. 0.97. What is the difference between the Female teachers (% of total teachers) in Egypt, Arab Rep. in 1979 and the Female teachers (% of total teachers) in Kuwait in 1984?
Offer a very short reply. -22.81. What is the difference between the Female teachers (% of total teachers) in Japan in 1979 and the Female teachers (% of total teachers) in Kuwait in 1984?
Ensure brevity in your answer.  -25.3. What is the difference between the Female teachers (% of total teachers) in Heavily indebted poor countries in 1979 and the Female teachers (% of total teachers) in Egypt, Arab Rep. in 1986?
Offer a very short reply. -7.29. What is the difference between the Female teachers (% of total teachers) of Heavily indebted poor countries in 1979 and the Female teachers (% of total teachers) of Japan in 1986?
Ensure brevity in your answer.  0.19. What is the difference between the Female teachers (% of total teachers) in Heavily indebted poor countries in 1979 and the Female teachers (% of total teachers) in Kuwait in 1986?
Make the answer very short. -23.55. What is the difference between the Female teachers (% of total teachers) in Egypt, Arab Rep. in 1979 and the Female teachers (% of total teachers) in Japan in 1986?
Offer a very short reply. 0.25. What is the difference between the Female teachers (% of total teachers) in Egypt, Arab Rep. in 1979 and the Female teachers (% of total teachers) in Kuwait in 1986?
Provide a short and direct response. -23.49. What is the difference between the Female teachers (% of total teachers) of Japan in 1979 and the Female teachers (% of total teachers) of Kuwait in 1986?
Ensure brevity in your answer.  -25.98. What is the difference between the Female teachers (% of total teachers) in Heavily indebted poor countries in 1981 and the Female teachers (% of total teachers) in Egypt, Arab Rep. in 1982?
Keep it short and to the point. -4.72. What is the difference between the Female teachers (% of total teachers) in Heavily indebted poor countries in 1981 and the Female teachers (% of total teachers) in Japan in 1982?
Your answer should be compact. 1.07. What is the difference between the Female teachers (% of total teachers) in Heavily indebted poor countries in 1981 and the Female teachers (% of total teachers) in Kuwait in 1982?
Your answer should be compact. -22.99. What is the difference between the Female teachers (% of total teachers) of Egypt, Arab Rep. in 1981 and the Female teachers (% of total teachers) of Japan in 1982?
Make the answer very short. 4.78. What is the difference between the Female teachers (% of total teachers) in Egypt, Arab Rep. in 1981 and the Female teachers (% of total teachers) in Kuwait in 1982?
Your response must be concise. -19.28. What is the difference between the Female teachers (% of total teachers) of Japan in 1981 and the Female teachers (% of total teachers) of Kuwait in 1982?
Provide a succinct answer. -23.97. What is the difference between the Female teachers (% of total teachers) in Heavily indebted poor countries in 1981 and the Female teachers (% of total teachers) in Egypt, Arab Rep. in 1983?
Your response must be concise. -5.92. What is the difference between the Female teachers (% of total teachers) in Heavily indebted poor countries in 1981 and the Female teachers (% of total teachers) in Japan in 1983?
Keep it short and to the point. 0.24. What is the difference between the Female teachers (% of total teachers) in Heavily indebted poor countries in 1981 and the Female teachers (% of total teachers) in Kuwait in 1983?
Provide a succinct answer. -22.44. What is the difference between the Female teachers (% of total teachers) in Egypt, Arab Rep. in 1981 and the Female teachers (% of total teachers) in Japan in 1983?
Your response must be concise. 3.95. What is the difference between the Female teachers (% of total teachers) in Egypt, Arab Rep. in 1981 and the Female teachers (% of total teachers) in Kuwait in 1983?
Provide a short and direct response. -18.73. What is the difference between the Female teachers (% of total teachers) in Japan in 1981 and the Female teachers (% of total teachers) in Kuwait in 1983?
Your answer should be compact. -23.42. What is the difference between the Female teachers (% of total teachers) of Heavily indebted poor countries in 1981 and the Female teachers (% of total teachers) of Egypt, Arab Rep. in 1984?
Give a very brief answer. -6.83. What is the difference between the Female teachers (% of total teachers) in Heavily indebted poor countries in 1981 and the Female teachers (% of total teachers) in Japan in 1984?
Keep it short and to the point. 0.04. What is the difference between the Female teachers (% of total teachers) of Heavily indebted poor countries in 1981 and the Female teachers (% of total teachers) of Kuwait in 1984?
Ensure brevity in your answer.  -23.75. What is the difference between the Female teachers (% of total teachers) in Egypt, Arab Rep. in 1981 and the Female teachers (% of total teachers) in Japan in 1984?
Your response must be concise. 3.74. What is the difference between the Female teachers (% of total teachers) of Egypt, Arab Rep. in 1981 and the Female teachers (% of total teachers) of Kuwait in 1984?
Ensure brevity in your answer.  -20.04. What is the difference between the Female teachers (% of total teachers) of Japan in 1981 and the Female teachers (% of total teachers) of Kuwait in 1984?
Make the answer very short. -24.73. What is the difference between the Female teachers (% of total teachers) in Heavily indebted poor countries in 1981 and the Female teachers (% of total teachers) in Egypt, Arab Rep. in 1986?
Offer a terse response. -8.17. What is the difference between the Female teachers (% of total teachers) of Heavily indebted poor countries in 1981 and the Female teachers (% of total teachers) of Japan in 1986?
Offer a terse response. -0.69. What is the difference between the Female teachers (% of total teachers) of Heavily indebted poor countries in 1981 and the Female teachers (% of total teachers) of Kuwait in 1986?
Offer a terse response. -24.43. What is the difference between the Female teachers (% of total teachers) of Egypt, Arab Rep. in 1981 and the Female teachers (% of total teachers) of Japan in 1986?
Make the answer very short. 3.01. What is the difference between the Female teachers (% of total teachers) in Egypt, Arab Rep. in 1981 and the Female teachers (% of total teachers) in Kuwait in 1986?
Your answer should be compact. -20.72. What is the difference between the Female teachers (% of total teachers) of Japan in 1981 and the Female teachers (% of total teachers) of Kuwait in 1986?
Your answer should be compact. -25.41. What is the difference between the Female teachers (% of total teachers) of Heavily indebted poor countries in 1982 and the Female teachers (% of total teachers) of Egypt, Arab Rep. in 1983?
Your response must be concise. -5.89. What is the difference between the Female teachers (% of total teachers) in Heavily indebted poor countries in 1982 and the Female teachers (% of total teachers) in Japan in 1983?
Offer a terse response. 0.28. What is the difference between the Female teachers (% of total teachers) of Heavily indebted poor countries in 1982 and the Female teachers (% of total teachers) of Kuwait in 1983?
Provide a succinct answer. -22.4. What is the difference between the Female teachers (% of total teachers) of Egypt, Arab Rep. in 1982 and the Female teachers (% of total teachers) of Japan in 1983?
Provide a succinct answer. 4.96. What is the difference between the Female teachers (% of total teachers) of Egypt, Arab Rep. in 1982 and the Female teachers (% of total teachers) of Kuwait in 1983?
Your answer should be very brief. -17.72. What is the difference between the Female teachers (% of total teachers) in Japan in 1982 and the Female teachers (% of total teachers) in Kuwait in 1983?
Offer a terse response. -23.51. What is the difference between the Female teachers (% of total teachers) in Heavily indebted poor countries in 1982 and the Female teachers (% of total teachers) in Egypt, Arab Rep. in 1984?
Make the answer very short. -6.79. What is the difference between the Female teachers (% of total teachers) in Heavily indebted poor countries in 1982 and the Female teachers (% of total teachers) in Japan in 1984?
Your response must be concise. 0.07. What is the difference between the Female teachers (% of total teachers) in Heavily indebted poor countries in 1982 and the Female teachers (% of total teachers) in Kuwait in 1984?
Keep it short and to the point. -23.71. What is the difference between the Female teachers (% of total teachers) in Egypt, Arab Rep. in 1982 and the Female teachers (% of total teachers) in Japan in 1984?
Make the answer very short. 4.76. What is the difference between the Female teachers (% of total teachers) in Egypt, Arab Rep. in 1982 and the Female teachers (% of total teachers) in Kuwait in 1984?
Offer a very short reply. -19.03. What is the difference between the Female teachers (% of total teachers) of Japan in 1982 and the Female teachers (% of total teachers) of Kuwait in 1984?
Your answer should be compact. -24.82. What is the difference between the Female teachers (% of total teachers) of Heavily indebted poor countries in 1982 and the Female teachers (% of total teachers) of Egypt, Arab Rep. in 1986?
Provide a succinct answer. -8.13. What is the difference between the Female teachers (% of total teachers) in Heavily indebted poor countries in 1982 and the Female teachers (% of total teachers) in Japan in 1986?
Your answer should be very brief. -0.65. What is the difference between the Female teachers (% of total teachers) in Heavily indebted poor countries in 1982 and the Female teachers (% of total teachers) in Kuwait in 1986?
Provide a short and direct response. -24.39. What is the difference between the Female teachers (% of total teachers) in Egypt, Arab Rep. in 1982 and the Female teachers (% of total teachers) in Japan in 1986?
Provide a succinct answer. 4.03. What is the difference between the Female teachers (% of total teachers) of Egypt, Arab Rep. in 1982 and the Female teachers (% of total teachers) of Kuwait in 1986?
Make the answer very short. -19.71. What is the difference between the Female teachers (% of total teachers) of Japan in 1982 and the Female teachers (% of total teachers) of Kuwait in 1986?
Give a very brief answer. -25.5. What is the difference between the Female teachers (% of total teachers) of Heavily indebted poor countries in 1983 and the Female teachers (% of total teachers) of Egypt, Arab Rep. in 1984?
Ensure brevity in your answer.  -6.77. What is the difference between the Female teachers (% of total teachers) in Heavily indebted poor countries in 1983 and the Female teachers (% of total teachers) in Japan in 1984?
Your answer should be compact. 0.09. What is the difference between the Female teachers (% of total teachers) in Heavily indebted poor countries in 1983 and the Female teachers (% of total teachers) in Kuwait in 1984?
Keep it short and to the point. -23.69. What is the difference between the Female teachers (% of total teachers) in Egypt, Arab Rep. in 1983 and the Female teachers (% of total teachers) in Japan in 1984?
Make the answer very short. 5.96. What is the difference between the Female teachers (% of total teachers) in Egypt, Arab Rep. in 1983 and the Female teachers (% of total teachers) in Kuwait in 1984?
Keep it short and to the point. -17.83. What is the difference between the Female teachers (% of total teachers) of Japan in 1983 and the Female teachers (% of total teachers) of Kuwait in 1984?
Ensure brevity in your answer.  -23.99. What is the difference between the Female teachers (% of total teachers) of Heavily indebted poor countries in 1983 and the Female teachers (% of total teachers) of Egypt, Arab Rep. in 1986?
Keep it short and to the point. -8.11. What is the difference between the Female teachers (% of total teachers) in Heavily indebted poor countries in 1983 and the Female teachers (% of total teachers) in Japan in 1986?
Offer a terse response. -0.63. What is the difference between the Female teachers (% of total teachers) in Heavily indebted poor countries in 1983 and the Female teachers (% of total teachers) in Kuwait in 1986?
Ensure brevity in your answer.  -24.37. What is the difference between the Female teachers (% of total teachers) of Egypt, Arab Rep. in 1983 and the Female teachers (% of total teachers) of Japan in 1986?
Give a very brief answer. 5.23. What is the difference between the Female teachers (% of total teachers) in Egypt, Arab Rep. in 1983 and the Female teachers (% of total teachers) in Kuwait in 1986?
Keep it short and to the point. -18.5. What is the difference between the Female teachers (% of total teachers) in Japan in 1983 and the Female teachers (% of total teachers) in Kuwait in 1986?
Your answer should be very brief. -24.67. What is the difference between the Female teachers (% of total teachers) of Heavily indebted poor countries in 1984 and the Female teachers (% of total teachers) of Egypt, Arab Rep. in 1986?
Your answer should be compact. -8.06. What is the difference between the Female teachers (% of total teachers) in Heavily indebted poor countries in 1984 and the Female teachers (% of total teachers) in Japan in 1986?
Your answer should be very brief. -0.58. What is the difference between the Female teachers (% of total teachers) in Heavily indebted poor countries in 1984 and the Female teachers (% of total teachers) in Kuwait in 1986?
Offer a very short reply. -24.31. What is the difference between the Female teachers (% of total teachers) of Egypt, Arab Rep. in 1984 and the Female teachers (% of total teachers) of Japan in 1986?
Give a very brief answer. 6.13. What is the difference between the Female teachers (% of total teachers) of Egypt, Arab Rep. in 1984 and the Female teachers (% of total teachers) of Kuwait in 1986?
Your answer should be very brief. -17.6. What is the difference between the Female teachers (% of total teachers) in Japan in 1984 and the Female teachers (% of total teachers) in Kuwait in 1986?
Keep it short and to the point. -24.46. What is the average Female teachers (% of total teachers) in Heavily indebted poor countries per year?
Your answer should be very brief. 27.97. What is the average Female teachers (% of total teachers) of Egypt, Arab Rep. per year?
Your response must be concise. 31.39. What is the average Female teachers (% of total teachers) of Japan per year?
Keep it short and to the point. 26.37. What is the average Female teachers (% of total teachers) of Kuwait per year?
Give a very brief answer. 49.81. In the year 1977, what is the difference between the Female teachers (% of total teachers) in Heavily indebted poor countries and Female teachers (% of total teachers) in Egypt, Arab Rep.?
Offer a very short reply. 1.1. In the year 1977, what is the difference between the Female teachers (% of total teachers) of Heavily indebted poor countries and Female teachers (% of total teachers) of Japan?
Provide a short and direct response. 4.72. In the year 1977, what is the difference between the Female teachers (% of total teachers) of Heavily indebted poor countries and Female teachers (% of total teachers) of Kuwait?
Ensure brevity in your answer.  -18.95. In the year 1977, what is the difference between the Female teachers (% of total teachers) of Egypt, Arab Rep. and Female teachers (% of total teachers) of Japan?
Your answer should be very brief. 3.61. In the year 1977, what is the difference between the Female teachers (% of total teachers) in Egypt, Arab Rep. and Female teachers (% of total teachers) in Kuwait?
Your response must be concise. -20.05. In the year 1977, what is the difference between the Female teachers (% of total teachers) in Japan and Female teachers (% of total teachers) in Kuwait?
Provide a succinct answer. -23.66. In the year 1978, what is the difference between the Female teachers (% of total teachers) of Heavily indebted poor countries and Female teachers (% of total teachers) of Egypt, Arab Rep.?
Offer a very short reply. 0.27. In the year 1978, what is the difference between the Female teachers (% of total teachers) in Heavily indebted poor countries and Female teachers (% of total teachers) in Japan?
Provide a short and direct response. 3.37. In the year 1978, what is the difference between the Female teachers (% of total teachers) of Heavily indebted poor countries and Female teachers (% of total teachers) of Kuwait?
Provide a succinct answer. -19.6. In the year 1978, what is the difference between the Female teachers (% of total teachers) in Egypt, Arab Rep. and Female teachers (% of total teachers) in Japan?
Ensure brevity in your answer.  3.1. In the year 1978, what is the difference between the Female teachers (% of total teachers) of Egypt, Arab Rep. and Female teachers (% of total teachers) of Kuwait?
Provide a short and direct response. -19.87. In the year 1978, what is the difference between the Female teachers (% of total teachers) in Japan and Female teachers (% of total teachers) in Kuwait?
Make the answer very short. -22.96. In the year 1979, what is the difference between the Female teachers (% of total teachers) of Heavily indebted poor countries and Female teachers (% of total teachers) of Egypt, Arab Rep.?
Your answer should be very brief. -0.06. In the year 1979, what is the difference between the Female teachers (% of total teachers) of Heavily indebted poor countries and Female teachers (% of total teachers) of Japan?
Ensure brevity in your answer.  2.43. In the year 1979, what is the difference between the Female teachers (% of total teachers) of Heavily indebted poor countries and Female teachers (% of total teachers) of Kuwait?
Keep it short and to the point. -20.99. In the year 1979, what is the difference between the Female teachers (% of total teachers) in Egypt, Arab Rep. and Female teachers (% of total teachers) in Japan?
Make the answer very short. 2.49. In the year 1979, what is the difference between the Female teachers (% of total teachers) in Egypt, Arab Rep. and Female teachers (% of total teachers) in Kuwait?
Give a very brief answer. -20.93. In the year 1979, what is the difference between the Female teachers (% of total teachers) in Japan and Female teachers (% of total teachers) in Kuwait?
Ensure brevity in your answer.  -23.42. In the year 1981, what is the difference between the Female teachers (% of total teachers) in Heavily indebted poor countries and Female teachers (% of total teachers) in Egypt, Arab Rep.?
Your answer should be compact. -3.7. In the year 1981, what is the difference between the Female teachers (% of total teachers) in Heavily indebted poor countries and Female teachers (% of total teachers) in Japan?
Give a very brief answer. 0.98. In the year 1981, what is the difference between the Female teachers (% of total teachers) of Heavily indebted poor countries and Female teachers (% of total teachers) of Kuwait?
Your answer should be very brief. -22.26. In the year 1981, what is the difference between the Female teachers (% of total teachers) of Egypt, Arab Rep. and Female teachers (% of total teachers) of Japan?
Your answer should be compact. 4.69. In the year 1981, what is the difference between the Female teachers (% of total teachers) in Egypt, Arab Rep. and Female teachers (% of total teachers) in Kuwait?
Your answer should be compact. -18.56. In the year 1981, what is the difference between the Female teachers (% of total teachers) of Japan and Female teachers (% of total teachers) of Kuwait?
Give a very brief answer. -23.24. In the year 1982, what is the difference between the Female teachers (% of total teachers) in Heavily indebted poor countries and Female teachers (% of total teachers) in Egypt, Arab Rep.?
Your answer should be compact. -4.68. In the year 1982, what is the difference between the Female teachers (% of total teachers) in Heavily indebted poor countries and Female teachers (% of total teachers) in Japan?
Your response must be concise. 1.11. In the year 1982, what is the difference between the Female teachers (% of total teachers) of Heavily indebted poor countries and Female teachers (% of total teachers) of Kuwait?
Provide a short and direct response. -22.95. In the year 1982, what is the difference between the Female teachers (% of total teachers) of Egypt, Arab Rep. and Female teachers (% of total teachers) of Japan?
Your answer should be compact. 5.79. In the year 1982, what is the difference between the Female teachers (% of total teachers) of Egypt, Arab Rep. and Female teachers (% of total teachers) of Kuwait?
Offer a terse response. -18.27. In the year 1982, what is the difference between the Female teachers (% of total teachers) of Japan and Female teachers (% of total teachers) of Kuwait?
Your answer should be compact. -24.06. In the year 1983, what is the difference between the Female teachers (% of total teachers) in Heavily indebted poor countries and Female teachers (% of total teachers) in Egypt, Arab Rep.?
Offer a very short reply. -5.86. In the year 1983, what is the difference between the Female teachers (% of total teachers) in Heavily indebted poor countries and Female teachers (% of total teachers) in Japan?
Keep it short and to the point. 0.3. In the year 1983, what is the difference between the Female teachers (% of total teachers) in Heavily indebted poor countries and Female teachers (% of total teachers) in Kuwait?
Your answer should be very brief. -22.38. In the year 1983, what is the difference between the Female teachers (% of total teachers) of Egypt, Arab Rep. and Female teachers (% of total teachers) of Japan?
Offer a very short reply. 6.17. In the year 1983, what is the difference between the Female teachers (% of total teachers) in Egypt, Arab Rep. and Female teachers (% of total teachers) in Kuwait?
Your answer should be compact. -16.51. In the year 1983, what is the difference between the Female teachers (% of total teachers) of Japan and Female teachers (% of total teachers) of Kuwait?
Your answer should be compact. -22.68. In the year 1984, what is the difference between the Female teachers (% of total teachers) in Heavily indebted poor countries and Female teachers (% of total teachers) in Egypt, Arab Rep.?
Keep it short and to the point. -6.71. In the year 1984, what is the difference between the Female teachers (% of total teachers) of Heavily indebted poor countries and Female teachers (% of total teachers) of Japan?
Your answer should be compact. 0.15. In the year 1984, what is the difference between the Female teachers (% of total teachers) of Heavily indebted poor countries and Female teachers (% of total teachers) of Kuwait?
Provide a short and direct response. -23.63. In the year 1984, what is the difference between the Female teachers (% of total teachers) in Egypt, Arab Rep. and Female teachers (% of total teachers) in Japan?
Offer a very short reply. 6.86. In the year 1984, what is the difference between the Female teachers (% of total teachers) of Egypt, Arab Rep. and Female teachers (% of total teachers) of Kuwait?
Your response must be concise. -16.92. In the year 1984, what is the difference between the Female teachers (% of total teachers) of Japan and Female teachers (% of total teachers) of Kuwait?
Your response must be concise. -23.79. In the year 1986, what is the difference between the Female teachers (% of total teachers) of Heavily indebted poor countries and Female teachers (% of total teachers) of Egypt, Arab Rep.?
Give a very brief answer. -7.71. In the year 1986, what is the difference between the Female teachers (% of total teachers) of Heavily indebted poor countries and Female teachers (% of total teachers) of Japan?
Your answer should be very brief. -0.23. In the year 1986, what is the difference between the Female teachers (% of total teachers) in Heavily indebted poor countries and Female teachers (% of total teachers) in Kuwait?
Provide a succinct answer. -23.96. In the year 1986, what is the difference between the Female teachers (% of total teachers) in Egypt, Arab Rep. and Female teachers (% of total teachers) in Japan?
Provide a succinct answer. 7.48. In the year 1986, what is the difference between the Female teachers (% of total teachers) in Egypt, Arab Rep. and Female teachers (% of total teachers) in Kuwait?
Provide a succinct answer. -16.26. In the year 1986, what is the difference between the Female teachers (% of total teachers) in Japan and Female teachers (% of total teachers) in Kuwait?
Give a very brief answer. -23.74. What is the ratio of the Female teachers (% of total teachers) in Heavily indebted poor countries in 1977 to that in 1978?
Provide a succinct answer. 1.03. What is the ratio of the Female teachers (% of total teachers) in Egypt, Arab Rep. in 1977 to that in 1978?
Provide a short and direct response. 1. What is the ratio of the Female teachers (% of total teachers) of Japan in 1977 to that in 1978?
Offer a terse response. 0.98. What is the ratio of the Female teachers (% of total teachers) of Kuwait in 1977 to that in 1978?
Your response must be concise. 1. What is the ratio of the Female teachers (% of total teachers) of Heavily indebted poor countries in 1977 to that in 1979?
Your response must be concise. 1.05. What is the ratio of the Female teachers (% of total teachers) in Egypt, Arab Rep. in 1977 to that in 1979?
Provide a succinct answer. 1.01. What is the ratio of the Female teachers (% of total teachers) of Japan in 1977 to that in 1979?
Your answer should be compact. 0.96. What is the ratio of the Female teachers (% of total teachers) of Kuwait in 1977 to that in 1979?
Make the answer very short. 0.99. What is the ratio of the Female teachers (% of total teachers) of Heavily indebted poor countries in 1977 to that in 1981?
Your response must be concise. 1.08. What is the ratio of the Female teachers (% of total teachers) of Egypt, Arab Rep. in 1977 to that in 1981?
Your answer should be compact. 0.92. What is the ratio of the Female teachers (% of total teachers) in Japan in 1977 to that in 1981?
Provide a short and direct response. 0.94. What is the ratio of the Female teachers (% of total teachers) in Kuwait in 1977 to that in 1981?
Keep it short and to the point. 0.98. What is the ratio of the Female teachers (% of total teachers) in Heavily indebted poor countries in 1977 to that in 1982?
Your answer should be compact. 1.08. What is the ratio of the Female teachers (% of total teachers) of Egypt, Arab Rep. in 1977 to that in 1982?
Provide a short and direct response. 0.89. What is the ratio of the Female teachers (% of total teachers) of Japan in 1977 to that in 1982?
Offer a terse response. 0.95. What is the ratio of the Female teachers (% of total teachers) in Kuwait in 1977 to that in 1982?
Your answer should be very brief. 0.96. What is the ratio of the Female teachers (% of total teachers) of Heavily indebted poor countries in 1977 to that in 1983?
Your answer should be compact. 1.08. What is the ratio of the Female teachers (% of total teachers) of Egypt, Arab Rep. in 1977 to that in 1983?
Offer a terse response. 0.86. What is the ratio of the Female teachers (% of total teachers) in Japan in 1977 to that in 1983?
Your answer should be very brief. 0.92. What is the ratio of the Female teachers (% of total teachers) in Kuwait in 1977 to that in 1983?
Provide a short and direct response. 0.98. What is the ratio of the Female teachers (% of total teachers) in Heavily indebted poor countries in 1977 to that in 1984?
Keep it short and to the point. 1.08. What is the ratio of the Female teachers (% of total teachers) of Egypt, Arab Rep. in 1977 to that in 1984?
Keep it short and to the point. 0.83. What is the ratio of the Female teachers (% of total teachers) of Japan in 1977 to that in 1984?
Make the answer very short. 0.91. What is the ratio of the Female teachers (% of total teachers) of Kuwait in 1977 to that in 1984?
Give a very brief answer. 0.95. What is the ratio of the Female teachers (% of total teachers) in Heavily indebted poor countries in 1977 to that in 1986?
Keep it short and to the point. 1.06. What is the ratio of the Female teachers (% of total teachers) of Egypt, Arab Rep. in 1977 to that in 1986?
Your answer should be compact. 0.8. What is the ratio of the Female teachers (% of total teachers) of Japan in 1977 to that in 1986?
Make the answer very short. 0.89. What is the ratio of the Female teachers (% of total teachers) in Kuwait in 1977 to that in 1986?
Your response must be concise. 0.94. What is the ratio of the Female teachers (% of total teachers) in Egypt, Arab Rep. in 1978 to that in 1979?
Your answer should be very brief. 1.01. What is the ratio of the Female teachers (% of total teachers) in Japan in 1978 to that in 1979?
Provide a succinct answer. 0.98. What is the ratio of the Female teachers (% of total teachers) in Kuwait in 1978 to that in 1979?
Offer a terse response. 0.98. What is the ratio of the Female teachers (% of total teachers) in Heavily indebted poor countries in 1978 to that in 1981?
Your answer should be compact. 1.05. What is the ratio of the Female teachers (% of total teachers) in Egypt, Arab Rep. in 1978 to that in 1981?
Your answer should be very brief. 0.92. What is the ratio of the Female teachers (% of total teachers) of Japan in 1978 to that in 1981?
Your answer should be compact. 0.96. What is the ratio of the Female teachers (% of total teachers) of Kuwait in 1978 to that in 1981?
Your answer should be very brief. 0.97. What is the ratio of the Female teachers (% of total teachers) of Heavily indebted poor countries in 1978 to that in 1982?
Offer a terse response. 1.05. What is the ratio of the Female teachers (% of total teachers) in Egypt, Arab Rep. in 1978 to that in 1982?
Offer a very short reply. 0.89. What is the ratio of the Female teachers (% of total teachers) in Japan in 1978 to that in 1982?
Offer a terse response. 0.97. What is the ratio of the Female teachers (% of total teachers) in Kuwait in 1978 to that in 1982?
Give a very brief answer. 0.96. What is the ratio of the Female teachers (% of total teachers) of Heavily indebted poor countries in 1978 to that in 1983?
Ensure brevity in your answer.  1.05. What is the ratio of the Female teachers (% of total teachers) in Egypt, Arab Rep. in 1978 to that in 1983?
Provide a succinct answer. 0.86. What is the ratio of the Female teachers (% of total teachers) of Japan in 1978 to that in 1983?
Your answer should be very brief. 0.94. What is the ratio of the Female teachers (% of total teachers) of Kuwait in 1978 to that in 1983?
Give a very brief answer. 0.97. What is the ratio of the Female teachers (% of total teachers) of Heavily indebted poor countries in 1978 to that in 1984?
Your answer should be very brief. 1.05. What is the ratio of the Female teachers (% of total teachers) of Egypt, Arab Rep. in 1978 to that in 1984?
Make the answer very short. 0.83. What is the ratio of the Female teachers (% of total teachers) in Japan in 1978 to that in 1984?
Your answer should be very brief. 0.93. What is the ratio of the Female teachers (% of total teachers) of Kuwait in 1978 to that in 1984?
Your answer should be very brief. 0.95. What is the ratio of the Female teachers (% of total teachers) of Heavily indebted poor countries in 1978 to that in 1986?
Your response must be concise. 1.03. What is the ratio of the Female teachers (% of total teachers) in Egypt, Arab Rep. in 1978 to that in 1986?
Provide a short and direct response. 0.8. What is the ratio of the Female teachers (% of total teachers) in Japan in 1978 to that in 1986?
Offer a terse response. 0.91. What is the ratio of the Female teachers (% of total teachers) of Kuwait in 1978 to that in 1986?
Keep it short and to the point. 0.93. What is the ratio of the Female teachers (% of total teachers) in Heavily indebted poor countries in 1979 to that in 1981?
Provide a short and direct response. 1.03. What is the ratio of the Female teachers (% of total teachers) of Egypt, Arab Rep. in 1979 to that in 1981?
Provide a succinct answer. 0.91. What is the ratio of the Female teachers (% of total teachers) of Japan in 1979 to that in 1981?
Your response must be concise. 0.98. What is the ratio of the Female teachers (% of total teachers) of Heavily indebted poor countries in 1979 to that in 1982?
Ensure brevity in your answer.  1.03. What is the ratio of the Female teachers (% of total teachers) in Egypt, Arab Rep. in 1979 to that in 1982?
Provide a short and direct response. 0.88. What is the ratio of the Female teachers (% of total teachers) in Japan in 1979 to that in 1982?
Make the answer very short. 0.98. What is the ratio of the Female teachers (% of total teachers) in Kuwait in 1979 to that in 1982?
Make the answer very short. 0.98. What is the ratio of the Female teachers (% of total teachers) in Heavily indebted poor countries in 1979 to that in 1983?
Your answer should be compact. 1.03. What is the ratio of the Female teachers (% of total teachers) of Egypt, Arab Rep. in 1979 to that in 1983?
Keep it short and to the point. 0.85. What is the ratio of the Female teachers (% of total teachers) in Japan in 1979 to that in 1983?
Offer a terse response. 0.95. What is the ratio of the Female teachers (% of total teachers) of Kuwait in 1979 to that in 1983?
Your answer should be very brief. 0.99. What is the ratio of the Female teachers (% of total teachers) of Heavily indebted poor countries in 1979 to that in 1984?
Offer a terse response. 1.03. What is the ratio of the Female teachers (% of total teachers) in Egypt, Arab Rep. in 1979 to that in 1984?
Your response must be concise. 0.83. What is the ratio of the Female teachers (% of total teachers) of Japan in 1979 to that in 1984?
Make the answer very short. 0.94. What is the ratio of the Female teachers (% of total teachers) of Kuwait in 1979 to that in 1984?
Give a very brief answer. 0.96. What is the ratio of the Female teachers (% of total teachers) of Heavily indebted poor countries in 1979 to that in 1986?
Your answer should be compact. 1.01. What is the ratio of the Female teachers (% of total teachers) of Egypt, Arab Rep. in 1979 to that in 1986?
Provide a succinct answer. 0.8. What is the ratio of the Female teachers (% of total teachers) of Japan in 1979 to that in 1986?
Offer a terse response. 0.92. What is the ratio of the Female teachers (% of total teachers) of Kuwait in 1979 to that in 1986?
Your answer should be very brief. 0.95. What is the ratio of the Female teachers (% of total teachers) of Egypt, Arab Rep. in 1981 to that in 1982?
Your answer should be very brief. 0.97. What is the ratio of the Female teachers (% of total teachers) in Japan in 1981 to that in 1982?
Your answer should be very brief. 1. What is the ratio of the Female teachers (% of total teachers) of Kuwait in 1981 to that in 1982?
Keep it short and to the point. 0.99. What is the ratio of the Female teachers (% of total teachers) in Japan in 1981 to that in 1983?
Ensure brevity in your answer.  0.97. What is the ratio of the Female teachers (% of total teachers) in Kuwait in 1981 to that in 1983?
Ensure brevity in your answer.  1. What is the ratio of the Female teachers (% of total teachers) of Heavily indebted poor countries in 1981 to that in 1984?
Make the answer very short. 1. What is the ratio of the Female teachers (% of total teachers) in Egypt, Arab Rep. in 1981 to that in 1984?
Provide a short and direct response. 0.91. What is the ratio of the Female teachers (% of total teachers) in Japan in 1981 to that in 1984?
Provide a short and direct response. 0.97. What is the ratio of the Female teachers (% of total teachers) of Kuwait in 1981 to that in 1984?
Your answer should be very brief. 0.97. What is the ratio of the Female teachers (% of total teachers) of Heavily indebted poor countries in 1981 to that in 1986?
Your answer should be very brief. 0.98. What is the ratio of the Female teachers (% of total teachers) in Egypt, Arab Rep. in 1981 to that in 1986?
Your response must be concise. 0.87. What is the ratio of the Female teachers (% of total teachers) in Japan in 1981 to that in 1986?
Provide a succinct answer. 0.94. What is the ratio of the Female teachers (% of total teachers) in Kuwait in 1981 to that in 1986?
Keep it short and to the point. 0.96. What is the ratio of the Female teachers (% of total teachers) in Heavily indebted poor countries in 1982 to that in 1983?
Offer a very short reply. 1. What is the ratio of the Female teachers (% of total teachers) in Egypt, Arab Rep. in 1982 to that in 1983?
Offer a terse response. 0.96. What is the ratio of the Female teachers (% of total teachers) in Japan in 1982 to that in 1983?
Your answer should be compact. 0.97. What is the ratio of the Female teachers (% of total teachers) of Kuwait in 1982 to that in 1983?
Make the answer very short. 1.01. What is the ratio of the Female teachers (% of total teachers) of Egypt, Arab Rep. in 1982 to that in 1984?
Your response must be concise. 0.94. What is the ratio of the Female teachers (% of total teachers) of Japan in 1982 to that in 1984?
Provide a succinct answer. 0.96. What is the ratio of the Female teachers (% of total teachers) of Kuwait in 1982 to that in 1984?
Give a very brief answer. 0.99. What is the ratio of the Female teachers (% of total teachers) of Heavily indebted poor countries in 1982 to that in 1986?
Provide a short and direct response. 0.98. What is the ratio of the Female teachers (% of total teachers) of Egypt, Arab Rep. in 1982 to that in 1986?
Your answer should be very brief. 0.9. What is the ratio of the Female teachers (% of total teachers) of Japan in 1982 to that in 1986?
Keep it short and to the point. 0.94. What is the ratio of the Female teachers (% of total teachers) in Kuwait in 1982 to that in 1986?
Keep it short and to the point. 0.97. What is the ratio of the Female teachers (% of total teachers) of Egypt, Arab Rep. in 1983 to that in 1984?
Your answer should be compact. 0.97. What is the ratio of the Female teachers (% of total teachers) in Kuwait in 1983 to that in 1984?
Provide a succinct answer. 0.97. What is the ratio of the Female teachers (% of total teachers) in Heavily indebted poor countries in 1983 to that in 1986?
Make the answer very short. 0.99. What is the ratio of the Female teachers (% of total teachers) of Egypt, Arab Rep. in 1983 to that in 1986?
Offer a very short reply. 0.94. What is the ratio of the Female teachers (% of total teachers) in Japan in 1983 to that in 1986?
Offer a very short reply. 0.97. What is the ratio of the Female teachers (% of total teachers) in Kuwait in 1983 to that in 1986?
Keep it short and to the point. 0.96. What is the ratio of the Female teachers (% of total teachers) in Heavily indebted poor countries in 1984 to that in 1986?
Keep it short and to the point. 0.99. What is the ratio of the Female teachers (% of total teachers) of Egypt, Arab Rep. in 1984 to that in 1986?
Your response must be concise. 0.96. What is the ratio of the Female teachers (% of total teachers) of Kuwait in 1984 to that in 1986?
Provide a succinct answer. 0.99. What is the difference between the highest and the second highest Female teachers (% of total teachers) of Heavily indebted poor countries?
Offer a very short reply. 0.84. What is the difference between the highest and the second highest Female teachers (% of total teachers) of Egypt, Arab Rep.?
Offer a terse response. 1.35. What is the difference between the highest and the second highest Female teachers (% of total teachers) of Japan?
Give a very brief answer. 0.73. What is the difference between the highest and the second highest Female teachers (% of total teachers) in Kuwait?
Offer a terse response. 0.68. What is the difference between the highest and the lowest Female teachers (% of total teachers) of Heavily indebted poor countries?
Your answer should be compact. 2.25. What is the difference between the highest and the lowest Female teachers (% of total teachers) of Egypt, Arab Rep.?
Ensure brevity in your answer.  7.24. What is the difference between the highest and the lowest Female teachers (% of total teachers) in Japan?
Keep it short and to the point. 3.16. What is the difference between the highest and the lowest Female teachers (% of total teachers) in Kuwait?
Provide a succinct answer. 3.42. 